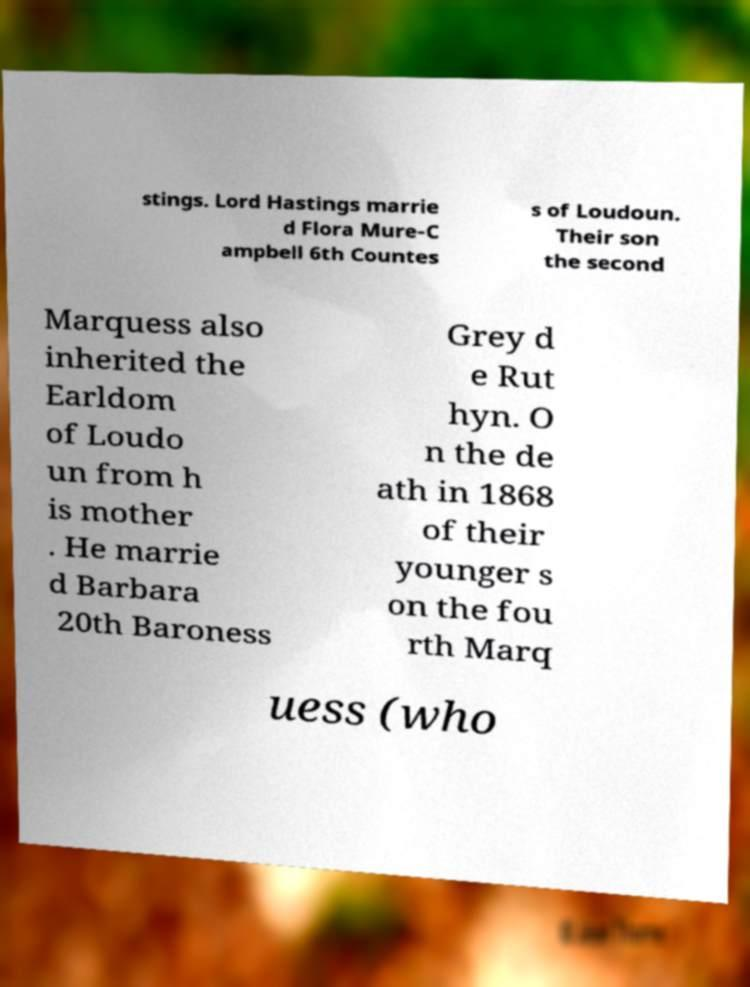I need the written content from this picture converted into text. Can you do that? stings. Lord Hastings marrie d Flora Mure-C ampbell 6th Countes s of Loudoun. Their son the second Marquess also inherited the Earldom of Loudo un from h is mother . He marrie d Barbara 20th Baroness Grey d e Rut hyn. O n the de ath in 1868 of their younger s on the fou rth Marq uess (who 